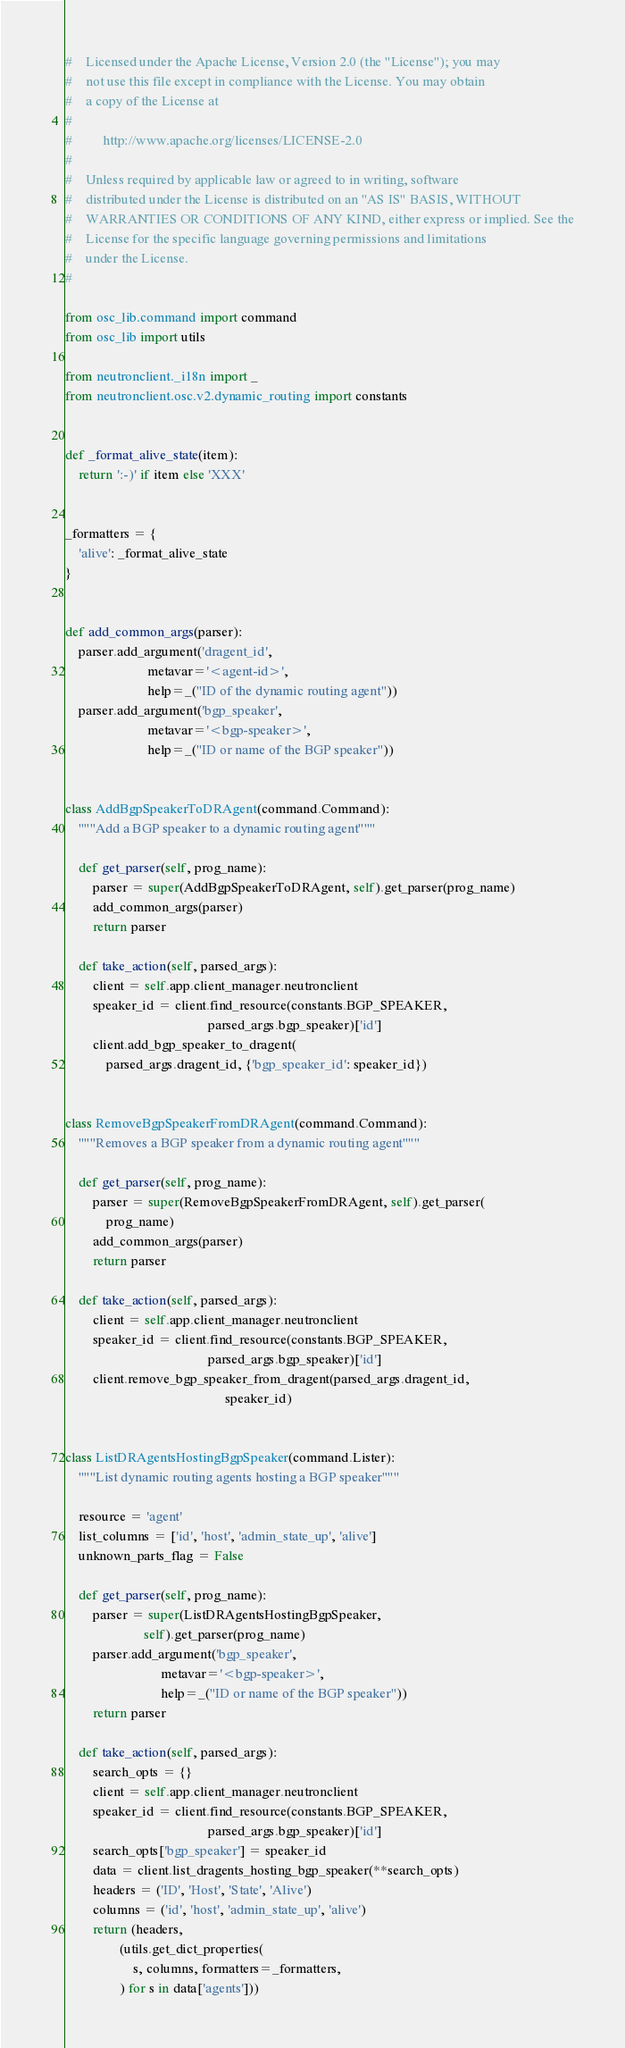<code> <loc_0><loc_0><loc_500><loc_500><_Python_>#    Licensed under the Apache License, Version 2.0 (the "License"); you may
#    not use this file except in compliance with the License. You may obtain
#    a copy of the License at
#
#         http://www.apache.org/licenses/LICENSE-2.0
#
#    Unless required by applicable law or agreed to in writing, software
#    distributed under the License is distributed on an "AS IS" BASIS, WITHOUT
#    WARRANTIES OR CONDITIONS OF ANY KIND, either express or implied. See the
#    License for the specific language governing permissions and limitations
#    under the License.
#

from osc_lib.command import command
from osc_lib import utils

from neutronclient._i18n import _
from neutronclient.osc.v2.dynamic_routing import constants


def _format_alive_state(item):
    return ':-)' if item else 'XXX'


_formatters = {
    'alive': _format_alive_state
}


def add_common_args(parser):
    parser.add_argument('dragent_id',
                        metavar='<agent-id>',
                        help=_("ID of the dynamic routing agent"))
    parser.add_argument('bgp_speaker',
                        metavar='<bgp-speaker>',
                        help=_("ID or name of the BGP speaker"))


class AddBgpSpeakerToDRAgent(command.Command):
    """Add a BGP speaker to a dynamic routing agent"""

    def get_parser(self, prog_name):
        parser = super(AddBgpSpeakerToDRAgent, self).get_parser(prog_name)
        add_common_args(parser)
        return parser

    def take_action(self, parsed_args):
        client = self.app.client_manager.neutronclient
        speaker_id = client.find_resource(constants.BGP_SPEAKER,
                                          parsed_args.bgp_speaker)['id']
        client.add_bgp_speaker_to_dragent(
            parsed_args.dragent_id, {'bgp_speaker_id': speaker_id})


class RemoveBgpSpeakerFromDRAgent(command.Command):
    """Removes a BGP speaker from a dynamic routing agent"""

    def get_parser(self, prog_name):
        parser = super(RemoveBgpSpeakerFromDRAgent, self).get_parser(
            prog_name)
        add_common_args(parser)
        return parser

    def take_action(self, parsed_args):
        client = self.app.client_manager.neutronclient
        speaker_id = client.find_resource(constants.BGP_SPEAKER,
                                          parsed_args.bgp_speaker)['id']
        client.remove_bgp_speaker_from_dragent(parsed_args.dragent_id,
                                               speaker_id)


class ListDRAgentsHostingBgpSpeaker(command.Lister):
    """List dynamic routing agents hosting a BGP speaker"""

    resource = 'agent'
    list_columns = ['id', 'host', 'admin_state_up', 'alive']
    unknown_parts_flag = False

    def get_parser(self, prog_name):
        parser = super(ListDRAgentsHostingBgpSpeaker,
                       self).get_parser(prog_name)
        parser.add_argument('bgp_speaker',
                            metavar='<bgp-speaker>',
                            help=_("ID or name of the BGP speaker"))
        return parser

    def take_action(self, parsed_args):
        search_opts = {}
        client = self.app.client_manager.neutronclient
        speaker_id = client.find_resource(constants.BGP_SPEAKER,
                                          parsed_args.bgp_speaker)['id']
        search_opts['bgp_speaker'] = speaker_id
        data = client.list_dragents_hosting_bgp_speaker(**search_opts)
        headers = ('ID', 'Host', 'State', 'Alive')
        columns = ('id', 'host', 'admin_state_up', 'alive')
        return (headers,
                (utils.get_dict_properties(
                    s, columns, formatters=_formatters,
                ) for s in data['agents']))
</code> 